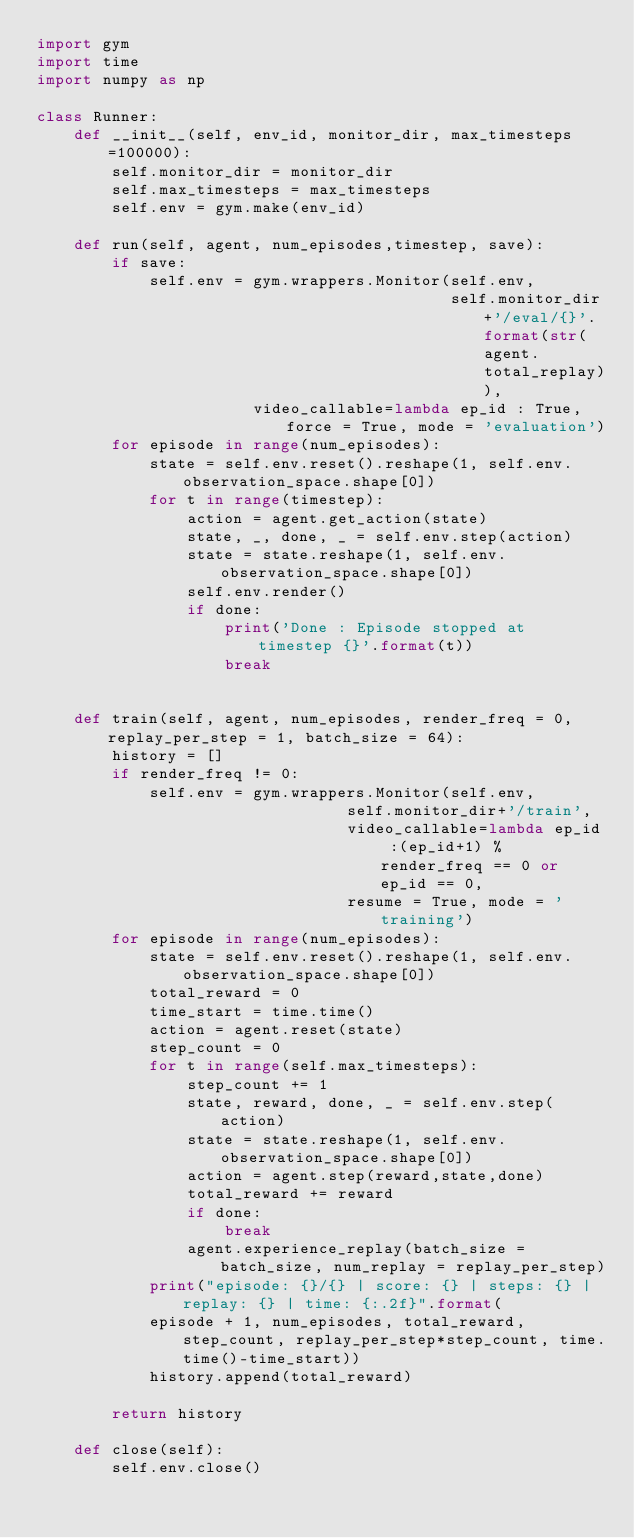<code> <loc_0><loc_0><loc_500><loc_500><_Python_>import gym
import time
import numpy as np

class Runner:
    def __init__(self, env_id, monitor_dir, max_timesteps=100000):
        self.monitor_dir = monitor_dir
        self.max_timesteps = max_timesteps
        self.env = gym.make(env_id)
    
    def run(self, agent, num_episodes,timestep, save):
        if save:
            self.env = gym.wrappers.Monitor(self.env,
                                            self.monitor_dir+'/eval/{}'.format(str(agent.total_replay)),
                       video_callable=lambda ep_id : True, force = True, mode = 'evaluation')
        for episode in range(num_episodes):
            state = self.env.reset().reshape(1, self.env.observation_space.shape[0])
            for t in range(timestep):
                action = agent.get_action(state)
                state, _, done, _ = self.env.step(action)
                state = state.reshape(1, self.env.observation_space.shape[0])
                self.env.render()
                if done:
                    print('Done : Episode stopped at timestep {}'.format(t))
                    break
            
    
    def train(self, agent, num_episodes, render_freq = 0, replay_per_step = 1, batch_size = 64):
        history = []
        if render_freq != 0:
            self.env = gym.wrappers.Monitor(self.env,
                                 self.monitor_dir+'/train',
                                 video_callable=lambda ep_id :(ep_id+1) % render_freq == 0 or ep_id == 0, 
                                 resume = True, mode = 'training')
        for episode in range(num_episodes):
            state = self.env.reset().reshape(1, self.env.observation_space.shape[0])
            total_reward = 0
            time_start = time.time()
            action = agent.reset(state)
            step_count = 0
            for t in range(self.max_timesteps):
                step_count += 1
                state, reward, done, _ = self.env.step(action)
                state = state.reshape(1, self.env.observation_space.shape[0])
                action = agent.step(reward,state,done)
                total_reward += reward
                if done:
                    break
                agent.experience_replay(batch_size = batch_size, num_replay = replay_per_step)
            print("episode: {}/{} | score: {} | steps: {} | replay: {} | time: {:.2f}".format(
            episode + 1, num_episodes, total_reward, step_count, replay_per_step*step_count, time.time()-time_start))
            history.append(total_reward)
            
        return history
    
    def close(self):
        self.env.close()</code> 